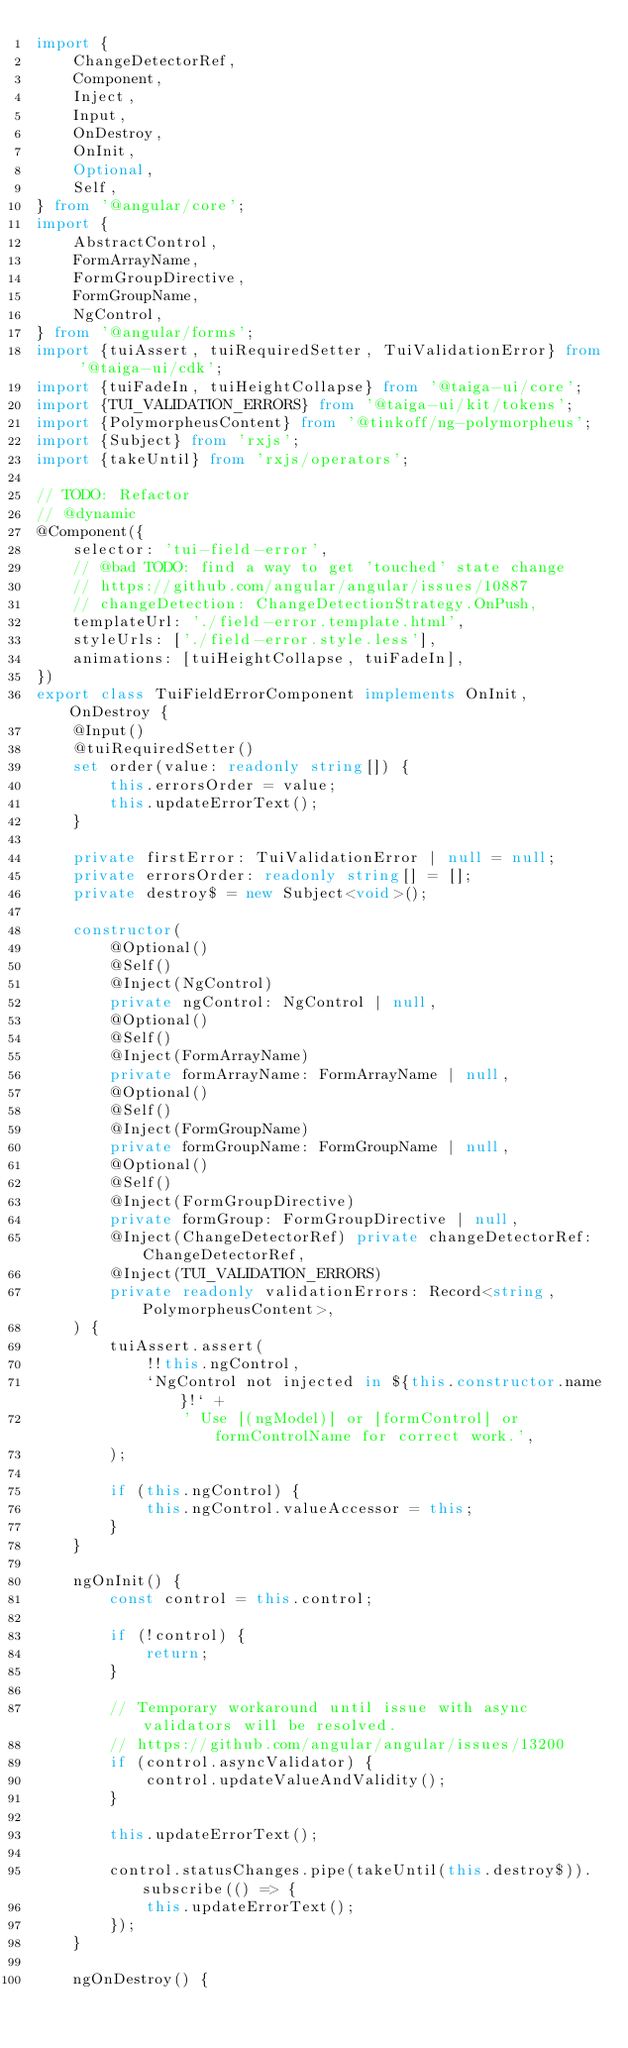Convert code to text. <code><loc_0><loc_0><loc_500><loc_500><_TypeScript_>import {
    ChangeDetectorRef,
    Component,
    Inject,
    Input,
    OnDestroy,
    OnInit,
    Optional,
    Self,
} from '@angular/core';
import {
    AbstractControl,
    FormArrayName,
    FormGroupDirective,
    FormGroupName,
    NgControl,
} from '@angular/forms';
import {tuiAssert, tuiRequiredSetter, TuiValidationError} from '@taiga-ui/cdk';
import {tuiFadeIn, tuiHeightCollapse} from '@taiga-ui/core';
import {TUI_VALIDATION_ERRORS} from '@taiga-ui/kit/tokens';
import {PolymorpheusContent} from '@tinkoff/ng-polymorpheus';
import {Subject} from 'rxjs';
import {takeUntil} from 'rxjs/operators';

// TODO: Refactor
// @dynamic
@Component({
    selector: 'tui-field-error',
    // @bad TODO: find a way to get 'touched' state change
    // https://github.com/angular/angular/issues/10887
    // changeDetection: ChangeDetectionStrategy.OnPush,
    templateUrl: './field-error.template.html',
    styleUrls: ['./field-error.style.less'],
    animations: [tuiHeightCollapse, tuiFadeIn],
})
export class TuiFieldErrorComponent implements OnInit, OnDestroy {
    @Input()
    @tuiRequiredSetter()
    set order(value: readonly string[]) {
        this.errorsOrder = value;
        this.updateErrorText();
    }

    private firstError: TuiValidationError | null = null;
    private errorsOrder: readonly string[] = [];
    private destroy$ = new Subject<void>();

    constructor(
        @Optional()
        @Self()
        @Inject(NgControl)
        private ngControl: NgControl | null,
        @Optional()
        @Self()
        @Inject(FormArrayName)
        private formArrayName: FormArrayName | null,
        @Optional()
        @Self()
        @Inject(FormGroupName)
        private formGroupName: FormGroupName | null,
        @Optional()
        @Self()
        @Inject(FormGroupDirective)
        private formGroup: FormGroupDirective | null,
        @Inject(ChangeDetectorRef) private changeDetectorRef: ChangeDetectorRef,
        @Inject(TUI_VALIDATION_ERRORS)
        private readonly validationErrors: Record<string, PolymorpheusContent>,
    ) {
        tuiAssert.assert(
            !!this.ngControl,
            `NgControl not injected in ${this.constructor.name}!` +
                ' Use [(ngModel)] or [formControl] or formControlName for correct work.',
        );

        if (this.ngControl) {
            this.ngControl.valueAccessor = this;
        }
    }

    ngOnInit() {
        const control = this.control;

        if (!control) {
            return;
        }

        // Temporary workaround until issue with async validators will be resolved.
        // https://github.com/angular/angular/issues/13200
        if (control.asyncValidator) {
            control.updateValueAndValidity();
        }

        this.updateErrorText();

        control.statusChanges.pipe(takeUntil(this.destroy$)).subscribe(() => {
            this.updateErrorText();
        });
    }

    ngOnDestroy() {</code> 